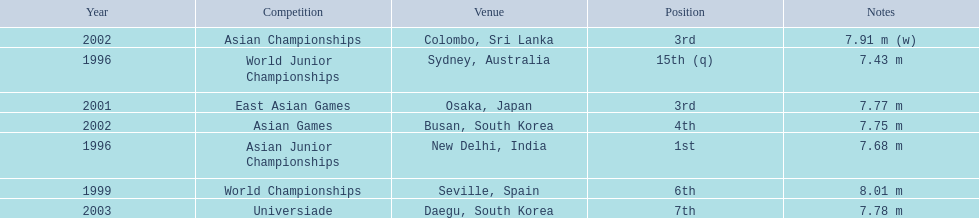Which competition did huang le achieve 3rd place? East Asian Games. Which competition did he achieve 4th place? Asian Games. When did he achieve 1st place? Asian Junior Championships. 